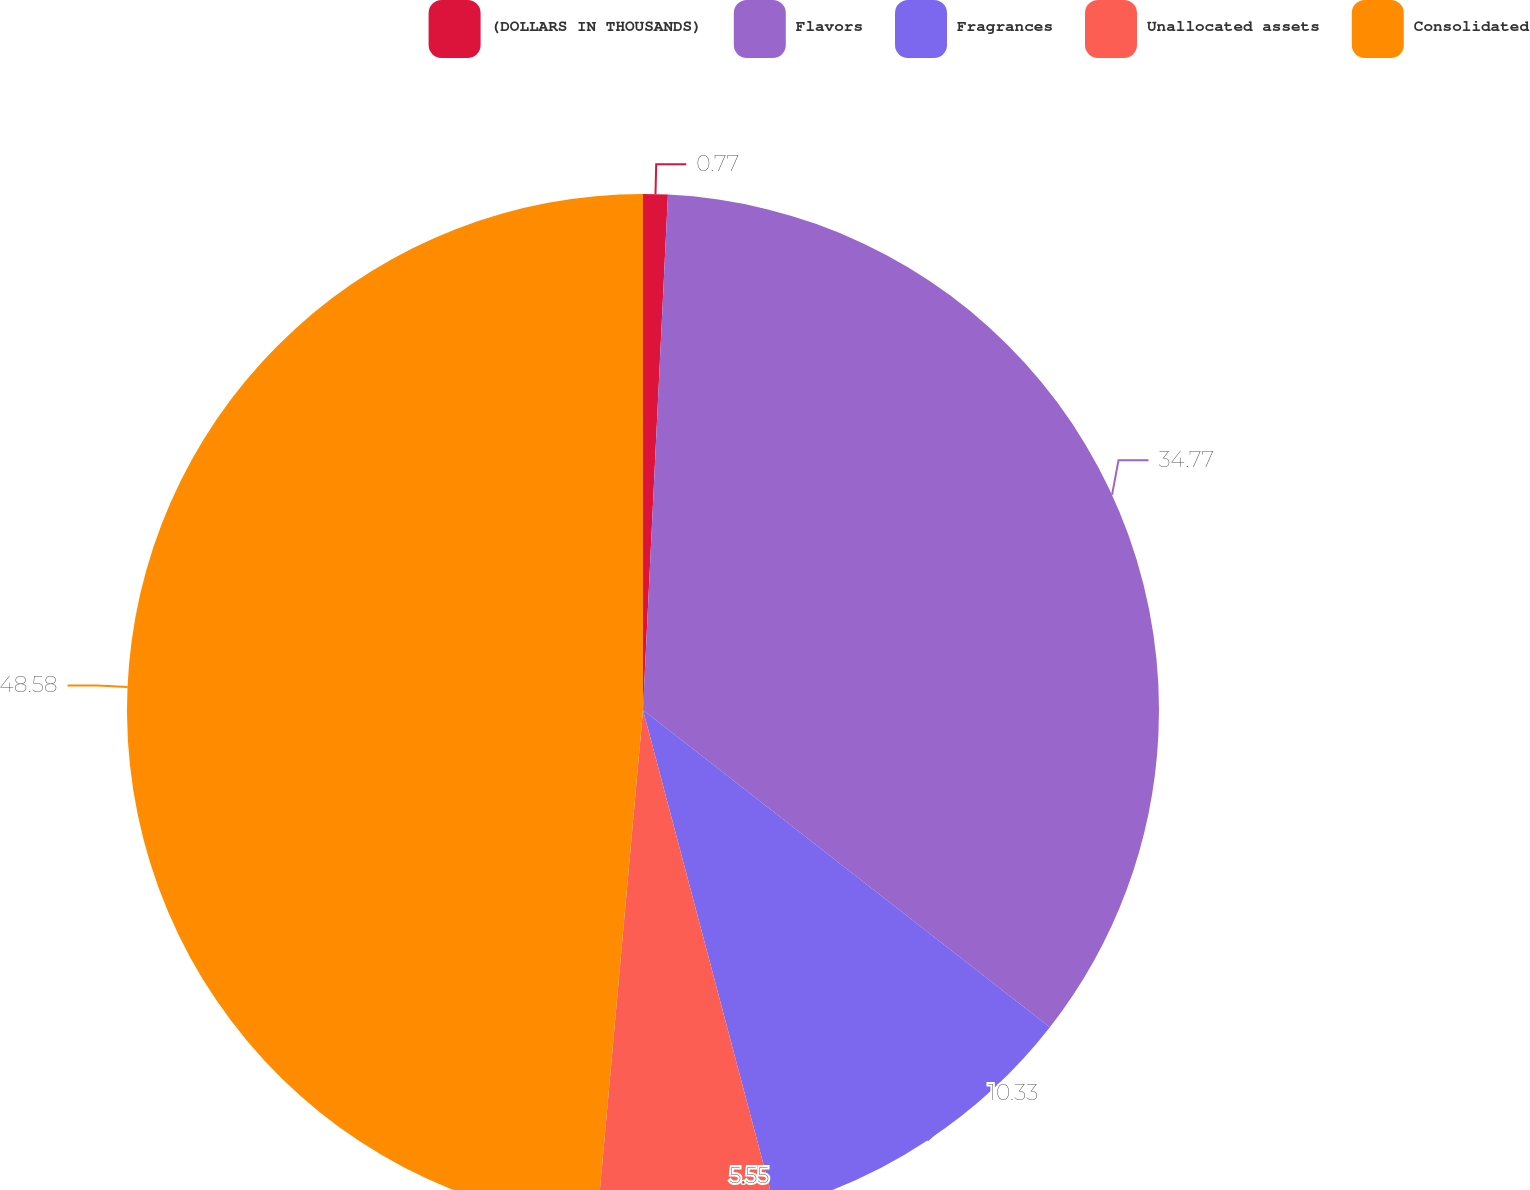Convert chart. <chart><loc_0><loc_0><loc_500><loc_500><pie_chart><fcel>(DOLLARS IN THOUSANDS)<fcel>Flavors<fcel>Fragrances<fcel>Unallocated assets<fcel>Consolidated<nl><fcel>0.77%<fcel>34.77%<fcel>10.33%<fcel>5.55%<fcel>48.57%<nl></chart> 